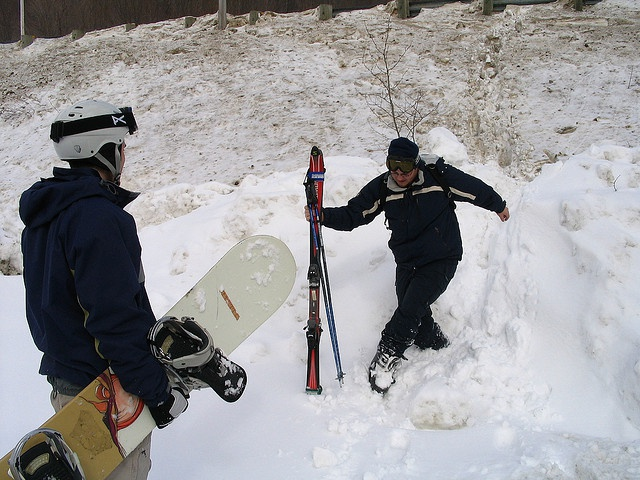Describe the objects in this image and their specific colors. I can see people in black, darkgray, gray, and lightgray tones, snowboard in black, darkgray, olive, and gray tones, people in black, gray, darkgray, and lightgray tones, and skis in black, maroon, gray, and darkgray tones in this image. 